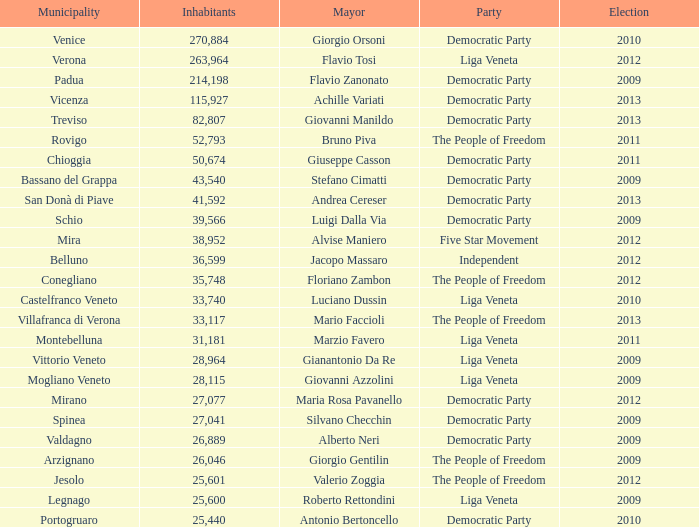In a mayoral election for stefano cimatti prior to 2009, how many inhabitants participated as members of the democratic party? 0.0. 